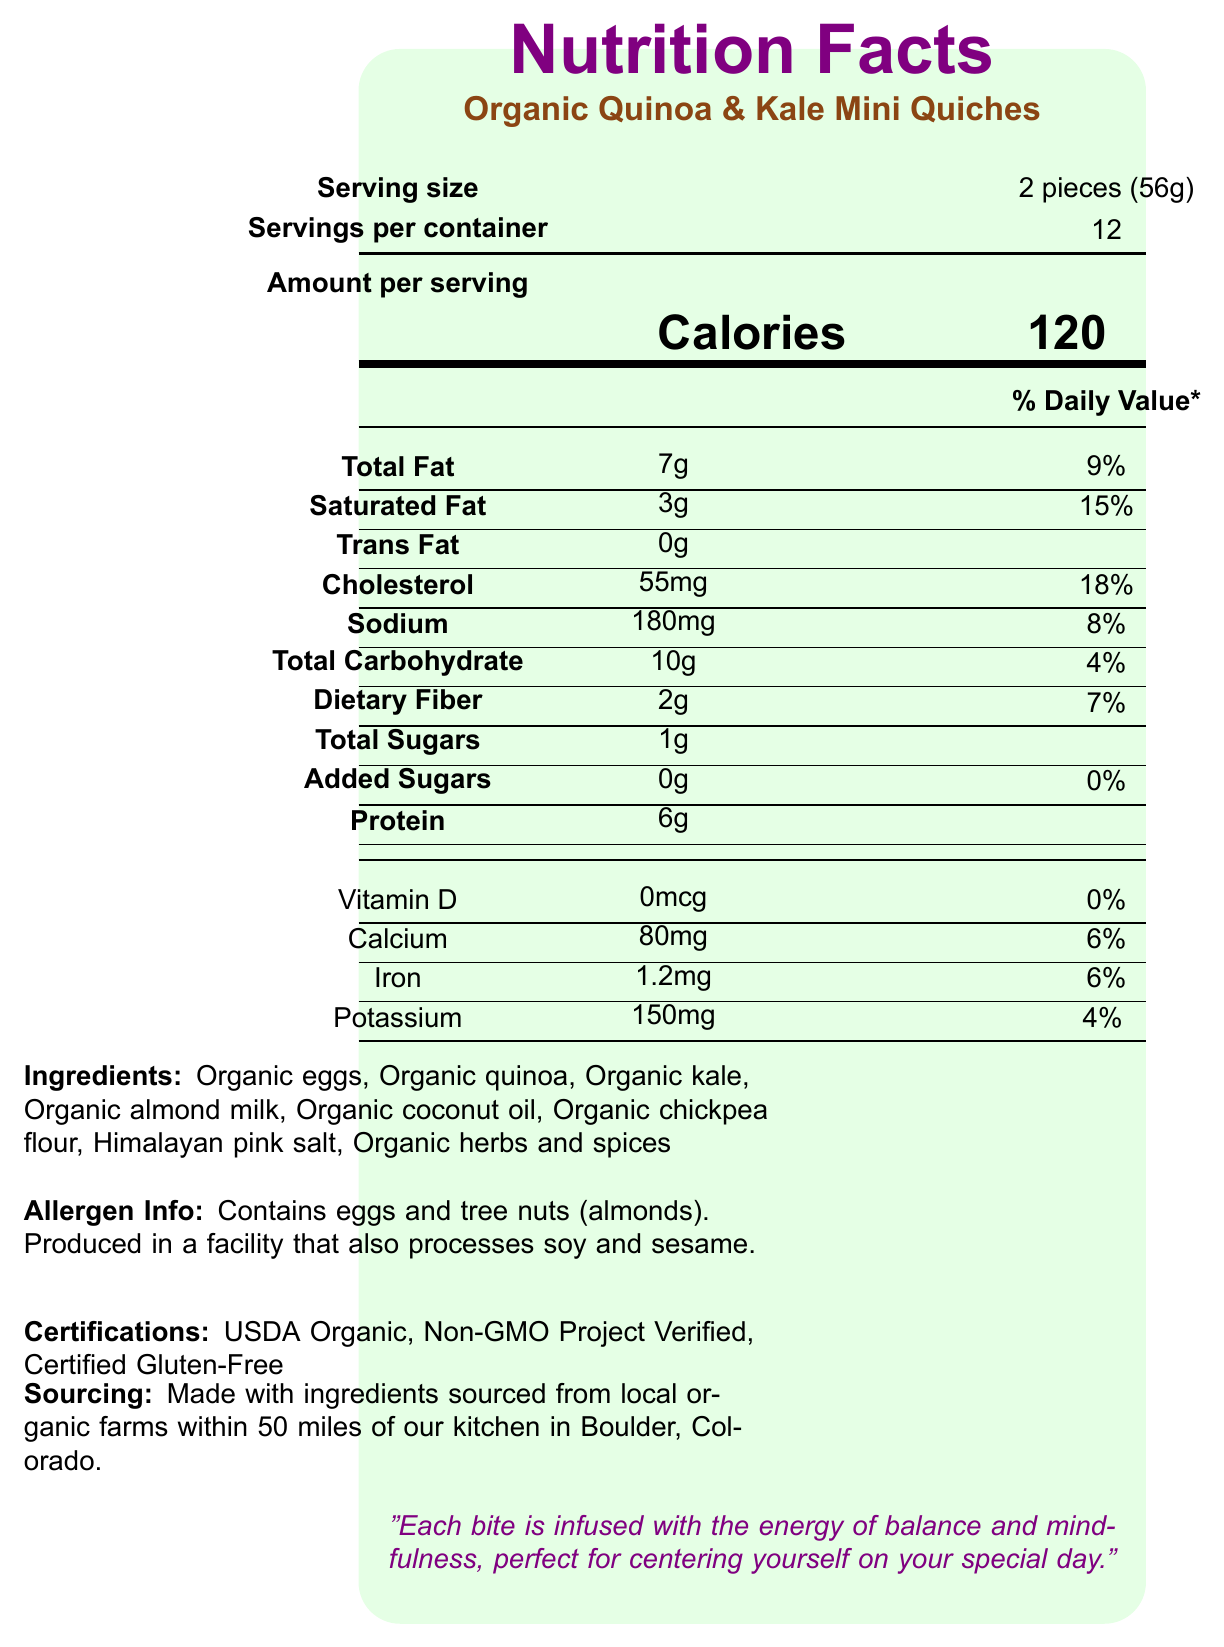what is the serving size? The serving size is stated as 2 pieces (56g) in the document.
Answer: 2 pieces (56g) how many calories are in one serving? The document states that the amount of calories per serving is 120.
Answer: 120 calories what percentage of the daily value of saturated fat does one serving contain? The saturated fat content is listed as 3g which is 15% of the daily value.
Answer: 15% how much dietary fiber is in one serving? The document indicates that each serving contains 2g of dietary fiber.
Answer: 2g what is the amount of protein per serving? The document lists the protein content per serving as 6g.
Answer: 6g which certification is NOT listed for this product? A. USDA Organic B. Non-GMO Project Verified C. Certified Gluten-Free D. Fair Trade Certified The certifications listed are USDA Organic, Non-GMO Project Verified, and Certified Gluten-Free. Fair Trade Certified is not mentioned.
Answer: D what is the daily value percentage for iron in one serving? A. 4% B. 6% C. 8% D. 10% The document states that one serving contains 1.2mg of iron, which is 6% of the daily value.
Answer: B is there any added sugar in the product? The document indicates that the added sugars amount is 0g, which means there is no added sugar.
Answer: No does the product contain any allergens? The allergen information specifies that the product contains eggs and tree nuts (almonds).
Answer: Yes describe the main idea of this document. The document is focused on informing the consumer about the nutritional benefits, ingredients, certifications, and sustainable practices involved in producing Organic Quinoa & Kale Mini Quiches. It also links the product to the theme of mindfulness and balance.
Answer: The document provides the detailed nutrition facts and other relevant information for Organic Quinoa & Kale Mini Quiches. This includes serving size, nutritional content per serving, ingredient list, allergen information, certifications, sourcing, sustainability notes, and a message of yoga inspiration. what is the sodium content per serving? Sodium content is listed as 180mg per serving in the document.
Answer: 180mg how many servings are there per container? The document states there are 12 servings per container.
Answer: 12 does the product support regenerative agriculture practices? The sustainability notes in the document mention that the product supports regenerative agriculture practices.
Answer: Yes what is the packaging material of the product made from? The document states that the packaging is made from 100% post-consumer recycled materials.
Answer: 100% post-consumer recycled materials how is the production process of this product classified? The document states that the production process of the product is carbon-neutral.
Answer: Carbon-neutral what is the source location for the ingredients? The document specifies that ingredients are sourced from local organic farms within 50 miles of the kitchen in Boulder, Colorado.
Answer: Ingredients are sourced from local organic farms within 50 miles of the kitchen in Boulder, Colorado. how much cholesterol is in one serving? The cholesterol content per serving is listed as 55mg in the document.
Answer: 55mg what is the potassium content percentage of the daily value? The document states that one serving contains 150mg of potassium, which is 4% of the daily value.
Answer: 4% what is the inspiration behind the product according to the document? The document mentions that each bite is infused with the energy of balance and mindfulness.
Answer: Balance and mindfulness how many grams of total carbohydrates are there in one serving? The total carbohydrate content per serving is listed as 10g.
Answer: 10g what is the vitamin d content in the product? The document shows that the vitamin D content is 0mcg per serving.
Answer: 0mcg is the facility where this product is produced processes sesame? The allergen information indicates that the facility also processes soy and sesame.
Answer: Yes how long have the local farms been operational? The document does not provide any information about the operational history of the local farms.
Answer: Not enough information 